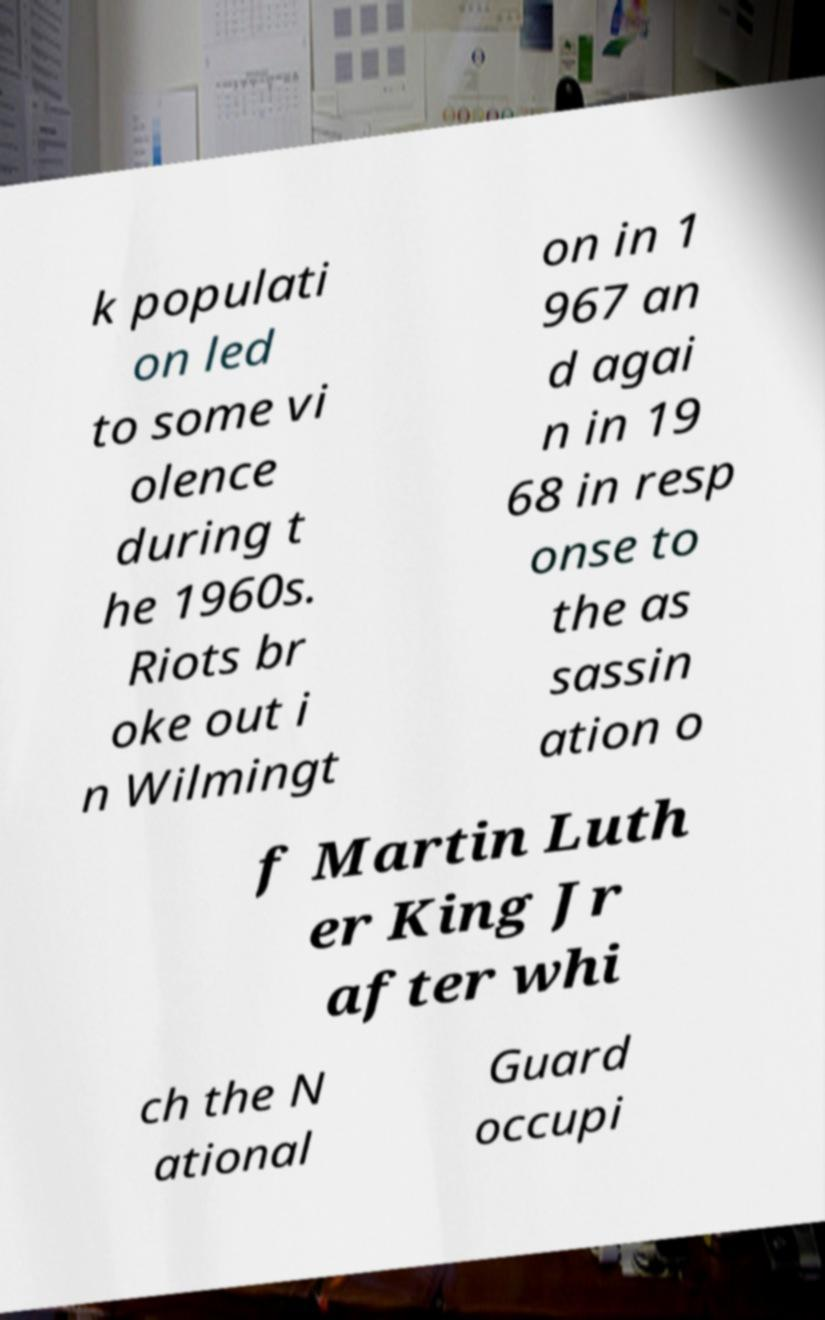Please identify and transcribe the text found in this image. k populati on led to some vi olence during t he 1960s. Riots br oke out i n Wilmingt on in 1 967 an d agai n in 19 68 in resp onse to the as sassin ation o f Martin Luth er King Jr after whi ch the N ational Guard occupi 